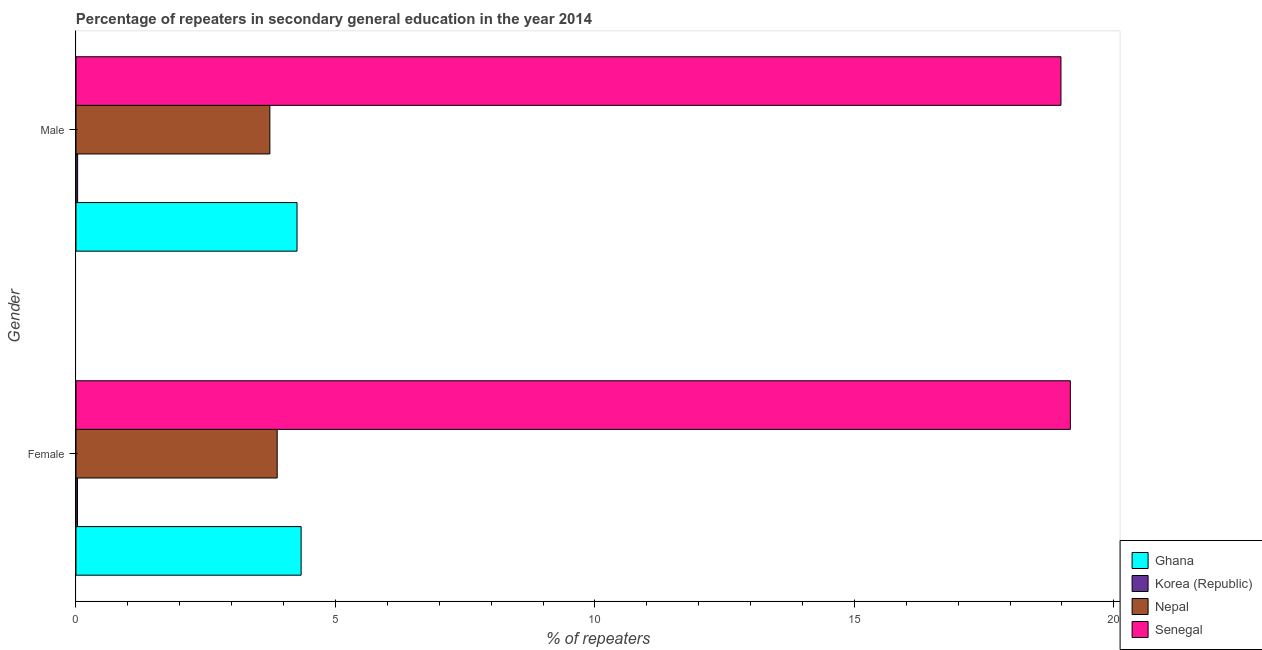How many groups of bars are there?
Offer a terse response. 2. Are the number of bars per tick equal to the number of legend labels?
Keep it short and to the point. Yes. Are the number of bars on each tick of the Y-axis equal?
Provide a succinct answer. Yes. How many bars are there on the 2nd tick from the bottom?
Offer a terse response. 4. What is the label of the 2nd group of bars from the top?
Make the answer very short. Female. What is the percentage of female repeaters in Nepal?
Provide a succinct answer. 3.88. Across all countries, what is the maximum percentage of male repeaters?
Provide a short and direct response. 18.98. Across all countries, what is the minimum percentage of male repeaters?
Ensure brevity in your answer.  0.03. In which country was the percentage of male repeaters maximum?
Provide a succinct answer. Senegal. What is the total percentage of male repeaters in the graph?
Your response must be concise. 27.01. What is the difference between the percentage of male repeaters in Nepal and that in Senegal?
Keep it short and to the point. -15.25. What is the difference between the percentage of female repeaters in Korea (Republic) and the percentage of male repeaters in Nepal?
Give a very brief answer. -3.71. What is the average percentage of female repeaters per country?
Provide a succinct answer. 6.85. What is the difference between the percentage of male repeaters and percentage of female repeaters in Nepal?
Your answer should be compact. -0.14. What is the ratio of the percentage of female repeaters in Nepal to that in Senegal?
Provide a short and direct response. 0.2. Is the percentage of female repeaters in Ghana less than that in Senegal?
Provide a short and direct response. Yes. What does the 4th bar from the top in Male represents?
Offer a very short reply. Ghana. What does the 3rd bar from the bottom in Male represents?
Ensure brevity in your answer.  Nepal. How many bars are there?
Offer a very short reply. 8. Are all the bars in the graph horizontal?
Provide a succinct answer. Yes. Where does the legend appear in the graph?
Give a very brief answer. Bottom right. How many legend labels are there?
Give a very brief answer. 4. What is the title of the graph?
Offer a very short reply. Percentage of repeaters in secondary general education in the year 2014. What is the label or title of the X-axis?
Ensure brevity in your answer.  % of repeaters. What is the % of repeaters in Ghana in Female?
Provide a short and direct response. 4.34. What is the % of repeaters in Korea (Republic) in Female?
Give a very brief answer. 0.03. What is the % of repeaters of Nepal in Female?
Your answer should be very brief. 3.88. What is the % of repeaters of Senegal in Female?
Offer a very short reply. 19.16. What is the % of repeaters of Ghana in Male?
Provide a short and direct response. 4.26. What is the % of repeaters of Korea (Republic) in Male?
Give a very brief answer. 0.03. What is the % of repeaters in Nepal in Male?
Your response must be concise. 3.74. What is the % of repeaters of Senegal in Male?
Make the answer very short. 18.98. Across all Gender, what is the maximum % of repeaters in Ghana?
Offer a terse response. 4.34. Across all Gender, what is the maximum % of repeaters of Korea (Republic)?
Your answer should be very brief. 0.03. Across all Gender, what is the maximum % of repeaters of Nepal?
Provide a short and direct response. 3.88. Across all Gender, what is the maximum % of repeaters of Senegal?
Your response must be concise. 19.16. Across all Gender, what is the minimum % of repeaters in Ghana?
Give a very brief answer. 4.26. Across all Gender, what is the minimum % of repeaters in Korea (Republic)?
Give a very brief answer. 0.03. Across all Gender, what is the minimum % of repeaters of Nepal?
Keep it short and to the point. 3.74. Across all Gender, what is the minimum % of repeaters of Senegal?
Give a very brief answer. 18.98. What is the total % of repeaters of Ghana in the graph?
Provide a short and direct response. 8.6. What is the total % of repeaters of Korea (Republic) in the graph?
Make the answer very short. 0.06. What is the total % of repeaters in Nepal in the graph?
Your answer should be compact. 7.61. What is the total % of repeaters of Senegal in the graph?
Offer a terse response. 38.15. What is the difference between the % of repeaters of Ghana in Female and that in Male?
Offer a very short reply. 0.08. What is the difference between the % of repeaters in Korea (Republic) in Female and that in Male?
Give a very brief answer. -0. What is the difference between the % of repeaters in Nepal in Female and that in Male?
Offer a terse response. 0.14. What is the difference between the % of repeaters of Senegal in Female and that in Male?
Provide a short and direct response. 0.18. What is the difference between the % of repeaters of Ghana in Female and the % of repeaters of Korea (Republic) in Male?
Give a very brief answer. 4.31. What is the difference between the % of repeaters in Ghana in Female and the % of repeaters in Nepal in Male?
Your answer should be compact. 0.6. What is the difference between the % of repeaters in Ghana in Female and the % of repeaters in Senegal in Male?
Ensure brevity in your answer.  -14.64. What is the difference between the % of repeaters in Korea (Republic) in Female and the % of repeaters in Nepal in Male?
Provide a short and direct response. -3.71. What is the difference between the % of repeaters of Korea (Republic) in Female and the % of repeaters of Senegal in Male?
Make the answer very short. -18.95. What is the difference between the % of repeaters of Nepal in Female and the % of repeaters of Senegal in Male?
Offer a terse response. -15.1. What is the average % of repeaters of Ghana per Gender?
Provide a succinct answer. 4.3. What is the average % of repeaters in Korea (Republic) per Gender?
Give a very brief answer. 0.03. What is the average % of repeaters in Nepal per Gender?
Offer a terse response. 3.81. What is the average % of repeaters in Senegal per Gender?
Give a very brief answer. 19.07. What is the difference between the % of repeaters in Ghana and % of repeaters in Korea (Republic) in Female?
Keep it short and to the point. 4.31. What is the difference between the % of repeaters of Ghana and % of repeaters of Nepal in Female?
Your response must be concise. 0.46. What is the difference between the % of repeaters of Ghana and % of repeaters of Senegal in Female?
Give a very brief answer. -14.82. What is the difference between the % of repeaters in Korea (Republic) and % of repeaters in Nepal in Female?
Make the answer very short. -3.85. What is the difference between the % of repeaters of Korea (Republic) and % of repeaters of Senegal in Female?
Provide a succinct answer. -19.13. What is the difference between the % of repeaters of Nepal and % of repeaters of Senegal in Female?
Your answer should be very brief. -15.29. What is the difference between the % of repeaters of Ghana and % of repeaters of Korea (Republic) in Male?
Keep it short and to the point. 4.23. What is the difference between the % of repeaters of Ghana and % of repeaters of Nepal in Male?
Ensure brevity in your answer.  0.52. What is the difference between the % of repeaters in Ghana and % of repeaters in Senegal in Male?
Give a very brief answer. -14.72. What is the difference between the % of repeaters in Korea (Republic) and % of repeaters in Nepal in Male?
Your response must be concise. -3.7. What is the difference between the % of repeaters of Korea (Republic) and % of repeaters of Senegal in Male?
Keep it short and to the point. -18.95. What is the difference between the % of repeaters of Nepal and % of repeaters of Senegal in Male?
Keep it short and to the point. -15.25. What is the ratio of the % of repeaters of Ghana in Female to that in Male?
Keep it short and to the point. 1.02. What is the ratio of the % of repeaters in Korea (Republic) in Female to that in Male?
Offer a very short reply. 0.93. What is the ratio of the % of repeaters of Nepal in Female to that in Male?
Offer a very short reply. 1.04. What is the ratio of the % of repeaters in Senegal in Female to that in Male?
Offer a terse response. 1.01. What is the difference between the highest and the second highest % of repeaters of Ghana?
Give a very brief answer. 0.08. What is the difference between the highest and the second highest % of repeaters of Korea (Republic)?
Offer a terse response. 0. What is the difference between the highest and the second highest % of repeaters in Nepal?
Offer a terse response. 0.14. What is the difference between the highest and the second highest % of repeaters of Senegal?
Provide a short and direct response. 0.18. What is the difference between the highest and the lowest % of repeaters of Ghana?
Provide a short and direct response. 0.08. What is the difference between the highest and the lowest % of repeaters in Korea (Republic)?
Provide a succinct answer. 0. What is the difference between the highest and the lowest % of repeaters in Nepal?
Offer a terse response. 0.14. What is the difference between the highest and the lowest % of repeaters of Senegal?
Ensure brevity in your answer.  0.18. 